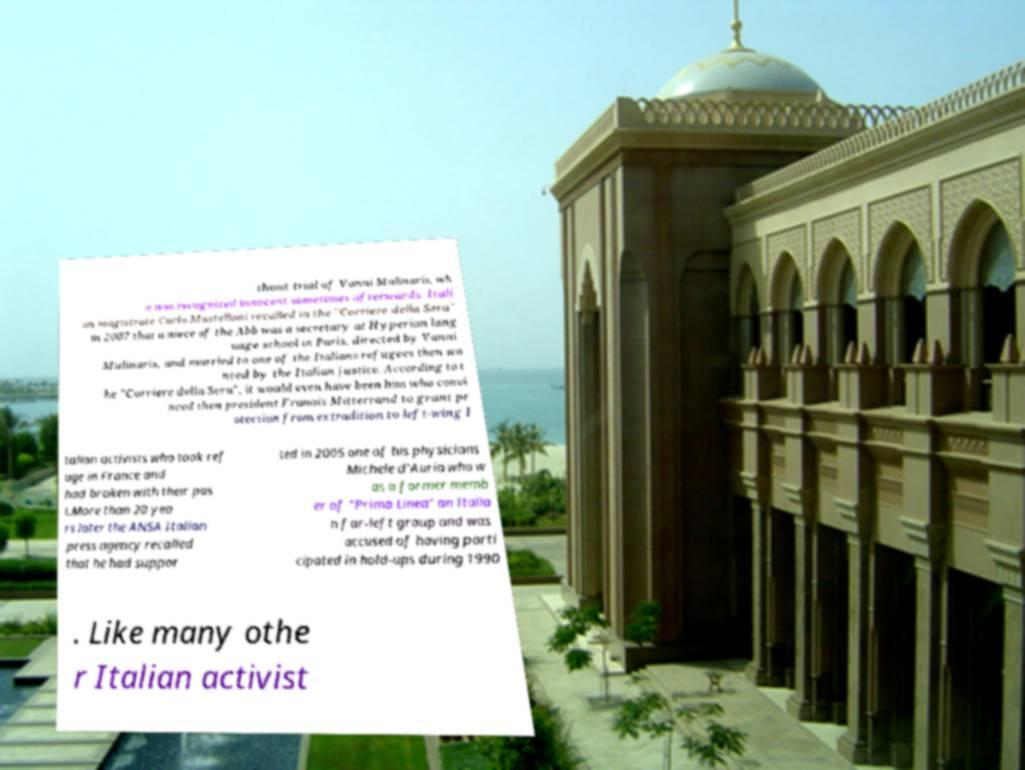Could you assist in decoding the text presented in this image and type it out clearly? thout trial of Vanni Mulinaris, wh o was recognized innocent sometimes afterwards. Itali an magistrate Carlo Mastelloni recalled in the "Corriere della Sera" in 2007 that a niece of the Abb was a secretary at Hyperion lang uage school in Paris, directed by Vanni Mulinaris, and married to one of the Italians refugees then wa nted by the Italian justice. According to t he "Corriere della Sera", it would even have been him who convi nced then president Franois Mitterrand to grant pr otection from extradition to left-wing I talian activists who took ref uge in France and had broken with their pas t.More than 20 yea rs later the ANSA Italian press agency recalled that he had suppor ted in 2005 one of his physicians Michele d'Auria who w as a former memb er of "Prima Linea" an Italia n far-left group and was accused of having parti cipated in hold-ups during 1990 . Like many othe r Italian activist 